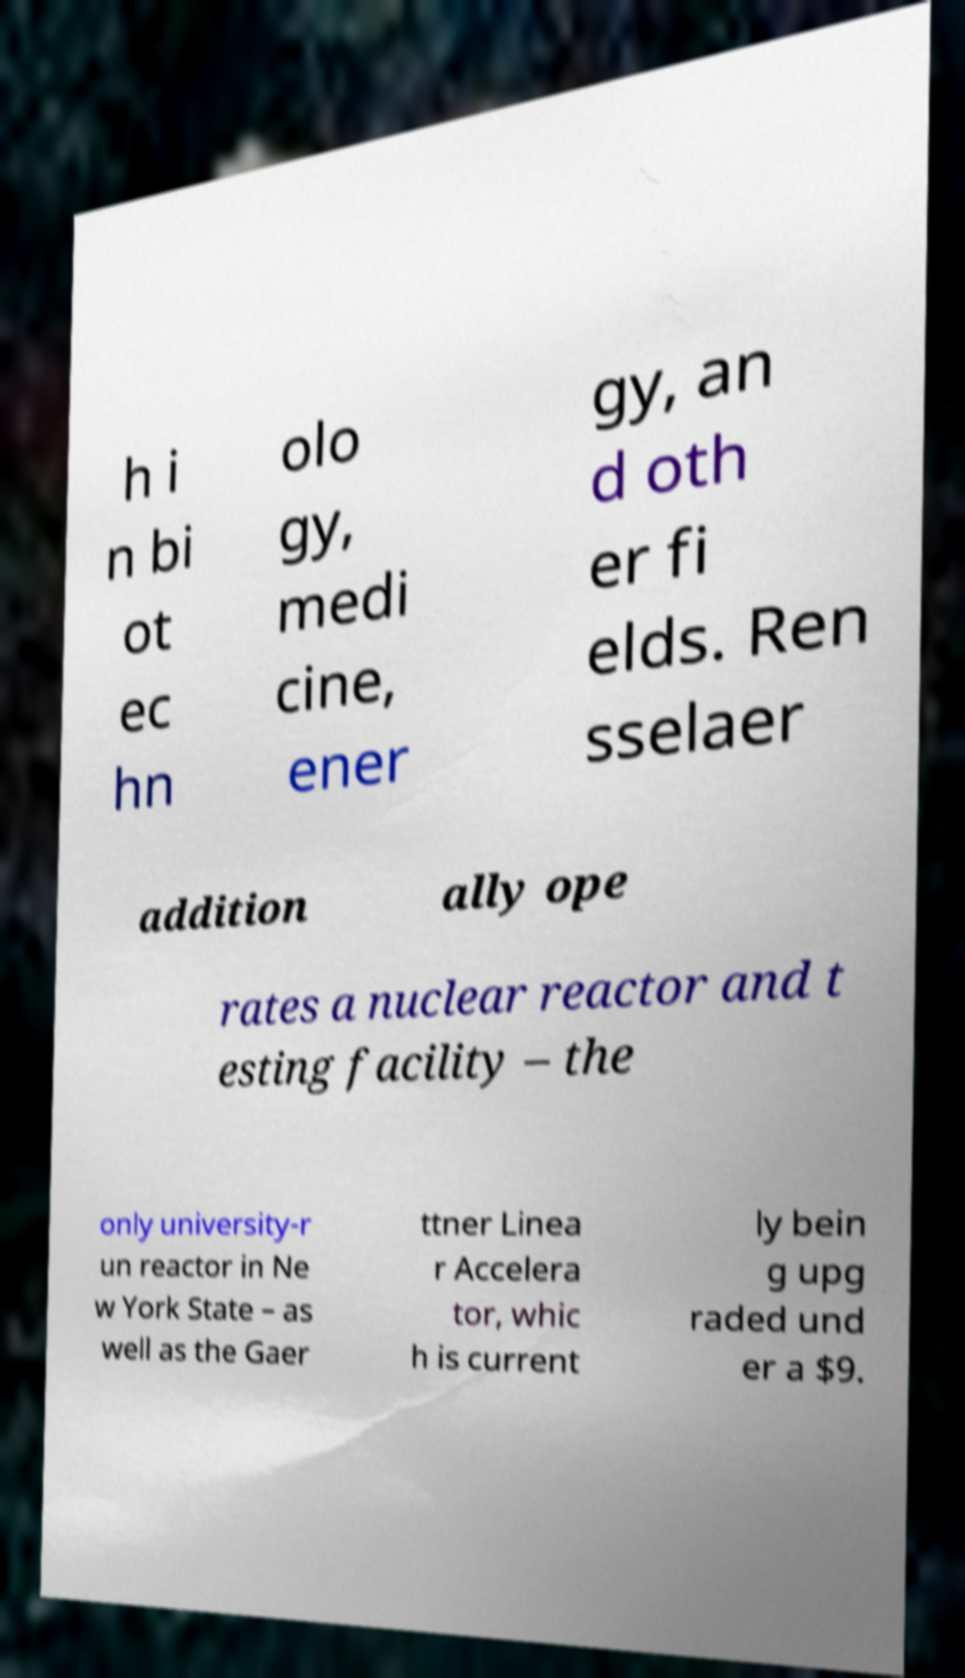What messages or text are displayed in this image? I need them in a readable, typed format. h i n bi ot ec hn olo gy, medi cine, ener gy, an d oth er fi elds. Ren sselaer addition ally ope rates a nuclear reactor and t esting facility – the only university-r un reactor in Ne w York State – as well as the Gaer ttner Linea r Accelera tor, whic h is current ly bein g upg raded und er a $9. 